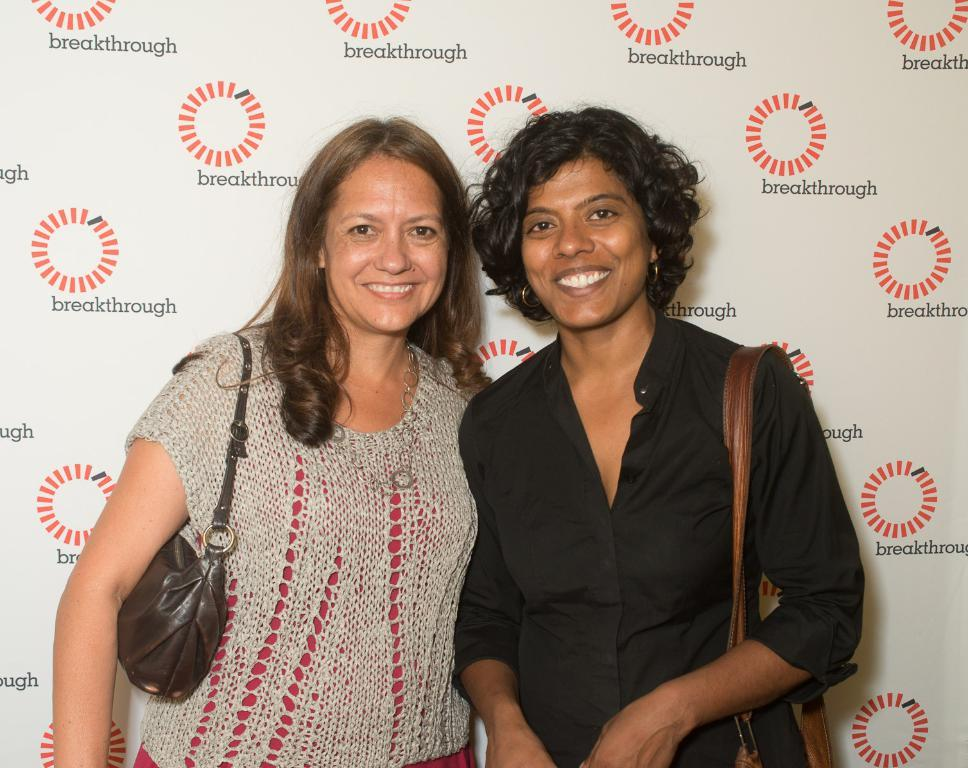How many people are in the image? There are two people in the image. What are the people doing in the image? The people are standing and smiling, and they are posing for a photo. What can be seen in the background of the image? There is a poster in the background of the image. What is featured on the poster? The poster contains text and logos. What type of cork can be seen on the tray in the image? There is no cork or tray present in the image. What is the people's desire in the image? The image does not convey any specific desires of the people; they are simply posing for a photo. 